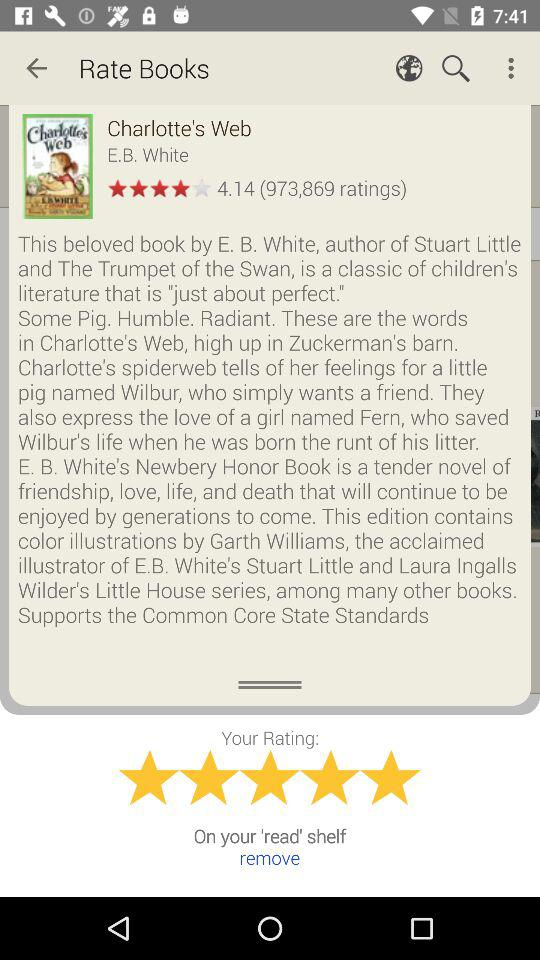What is the book's star rating? The book's star rating is 4.14. 